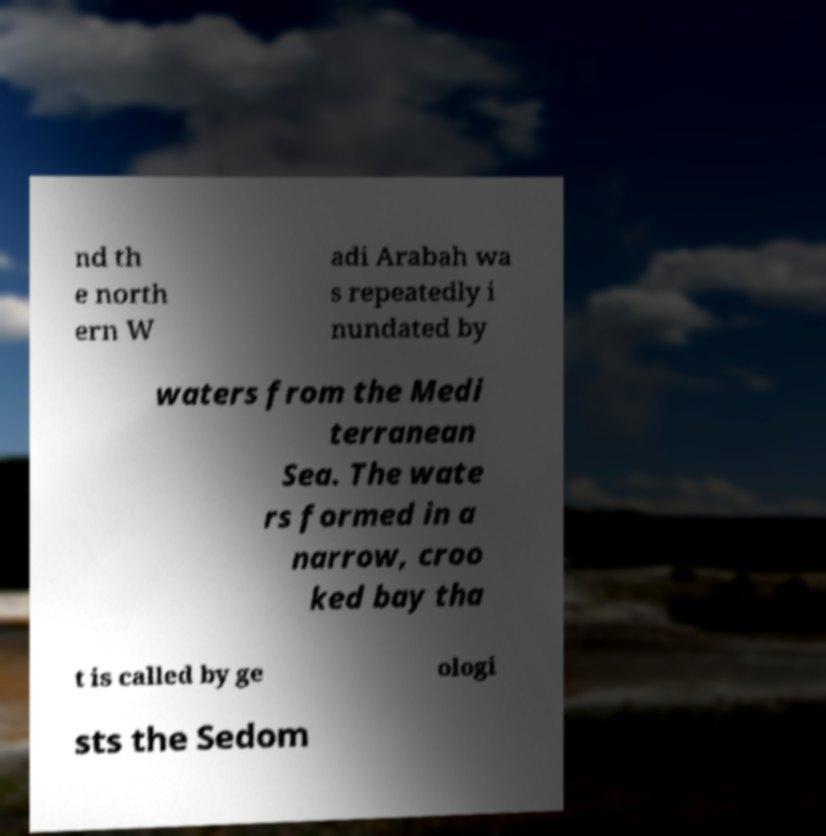There's text embedded in this image that I need extracted. Can you transcribe it verbatim? nd th e north ern W adi Arabah wa s repeatedly i nundated by waters from the Medi terranean Sea. The wate rs formed in a narrow, croo ked bay tha t is called by ge ologi sts the Sedom 